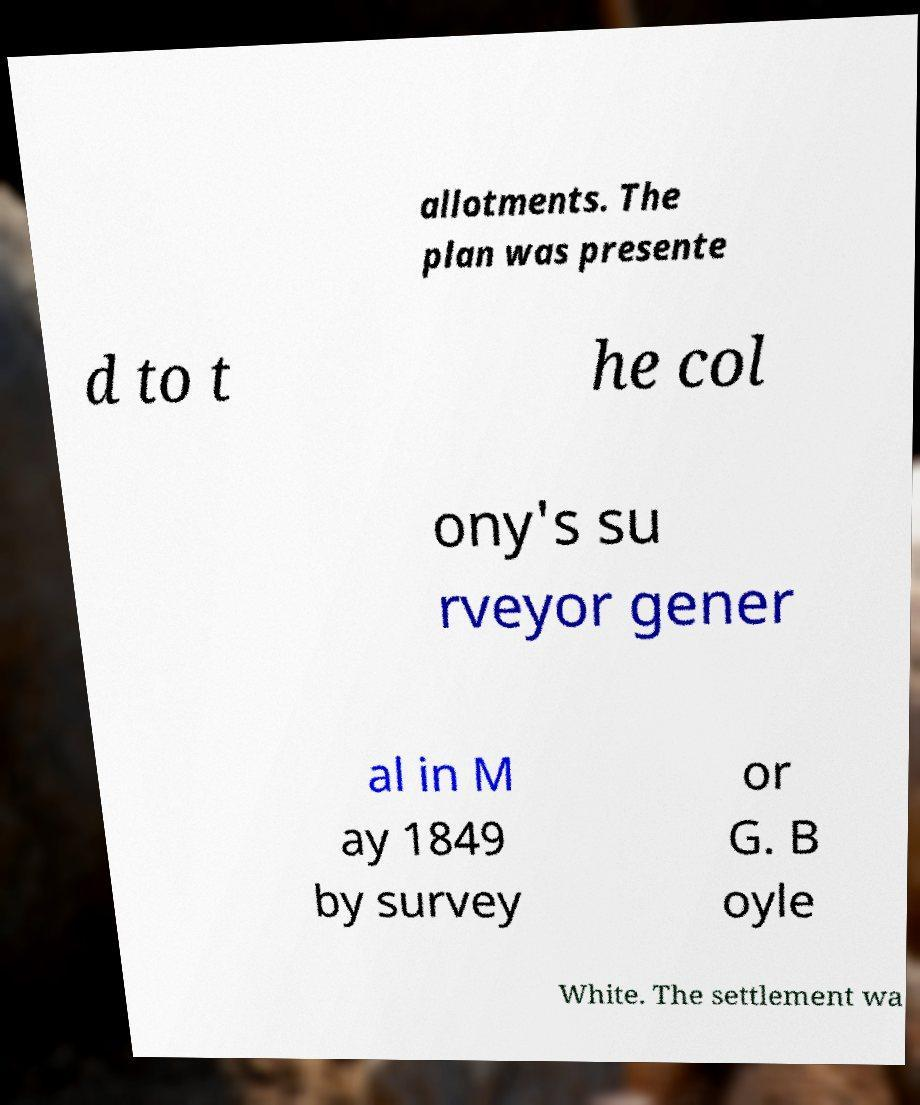Can you accurately transcribe the text from the provided image for me? allotments. The plan was presente d to t he col ony's su rveyor gener al in M ay 1849 by survey or G. B oyle White. The settlement wa 